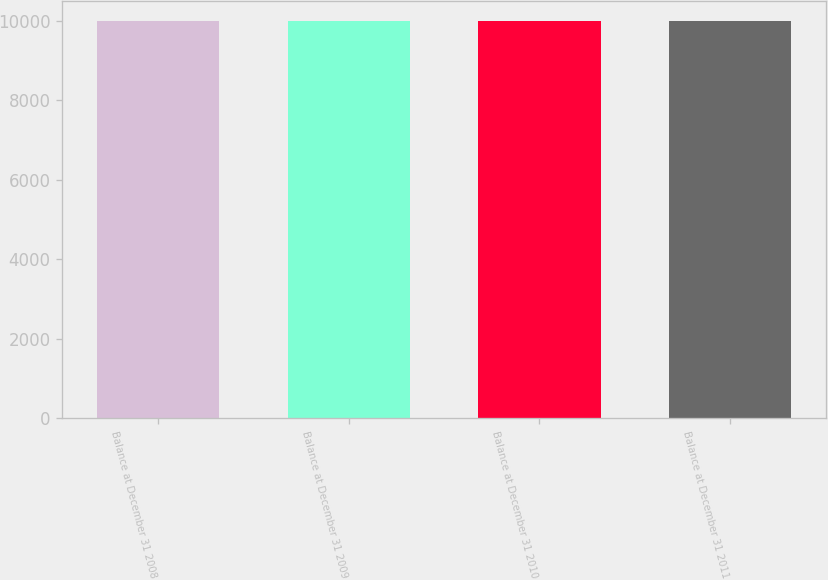Convert chart to OTSL. <chart><loc_0><loc_0><loc_500><loc_500><bar_chart><fcel>Balance at December 31 2008<fcel>Balance at December 31 2009<fcel>Balance at December 31 2010<fcel>Balance at December 31 2011<nl><fcel>10000<fcel>10000.1<fcel>10000.2<fcel>10000.3<nl></chart> 